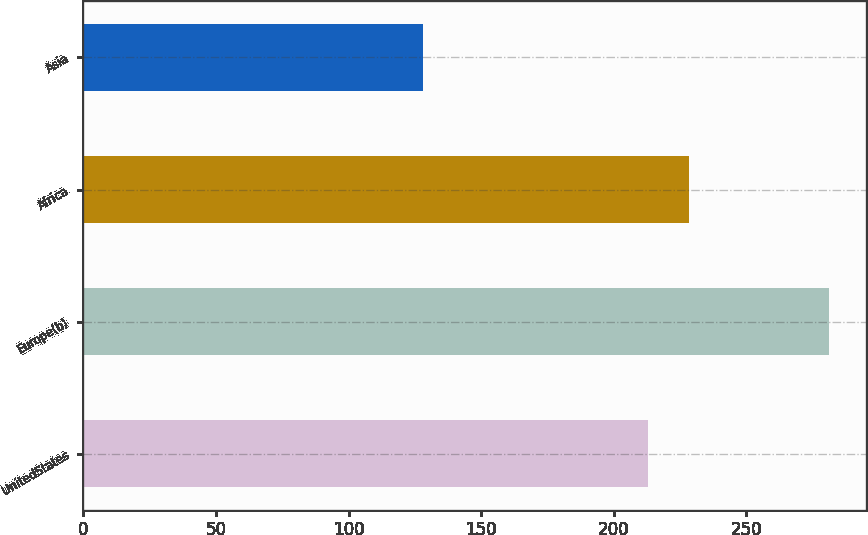<chart> <loc_0><loc_0><loc_500><loc_500><bar_chart><fcel>UnitedStates<fcel>Europe(b)<fcel>Africa<fcel>Asia<nl><fcel>213<fcel>281<fcel>228.3<fcel>128<nl></chart> 